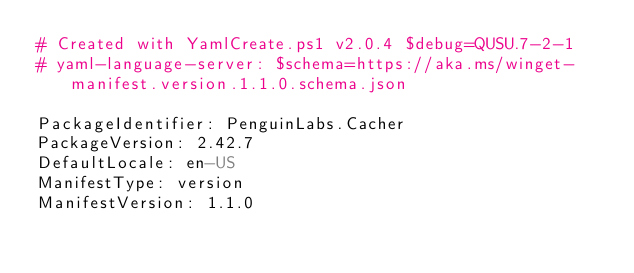<code> <loc_0><loc_0><loc_500><loc_500><_YAML_># Created with YamlCreate.ps1 v2.0.4 $debug=QUSU.7-2-1
# yaml-language-server: $schema=https://aka.ms/winget-manifest.version.1.1.0.schema.json

PackageIdentifier: PenguinLabs.Cacher
PackageVersion: 2.42.7
DefaultLocale: en-US
ManifestType: version
ManifestVersion: 1.1.0
</code> 